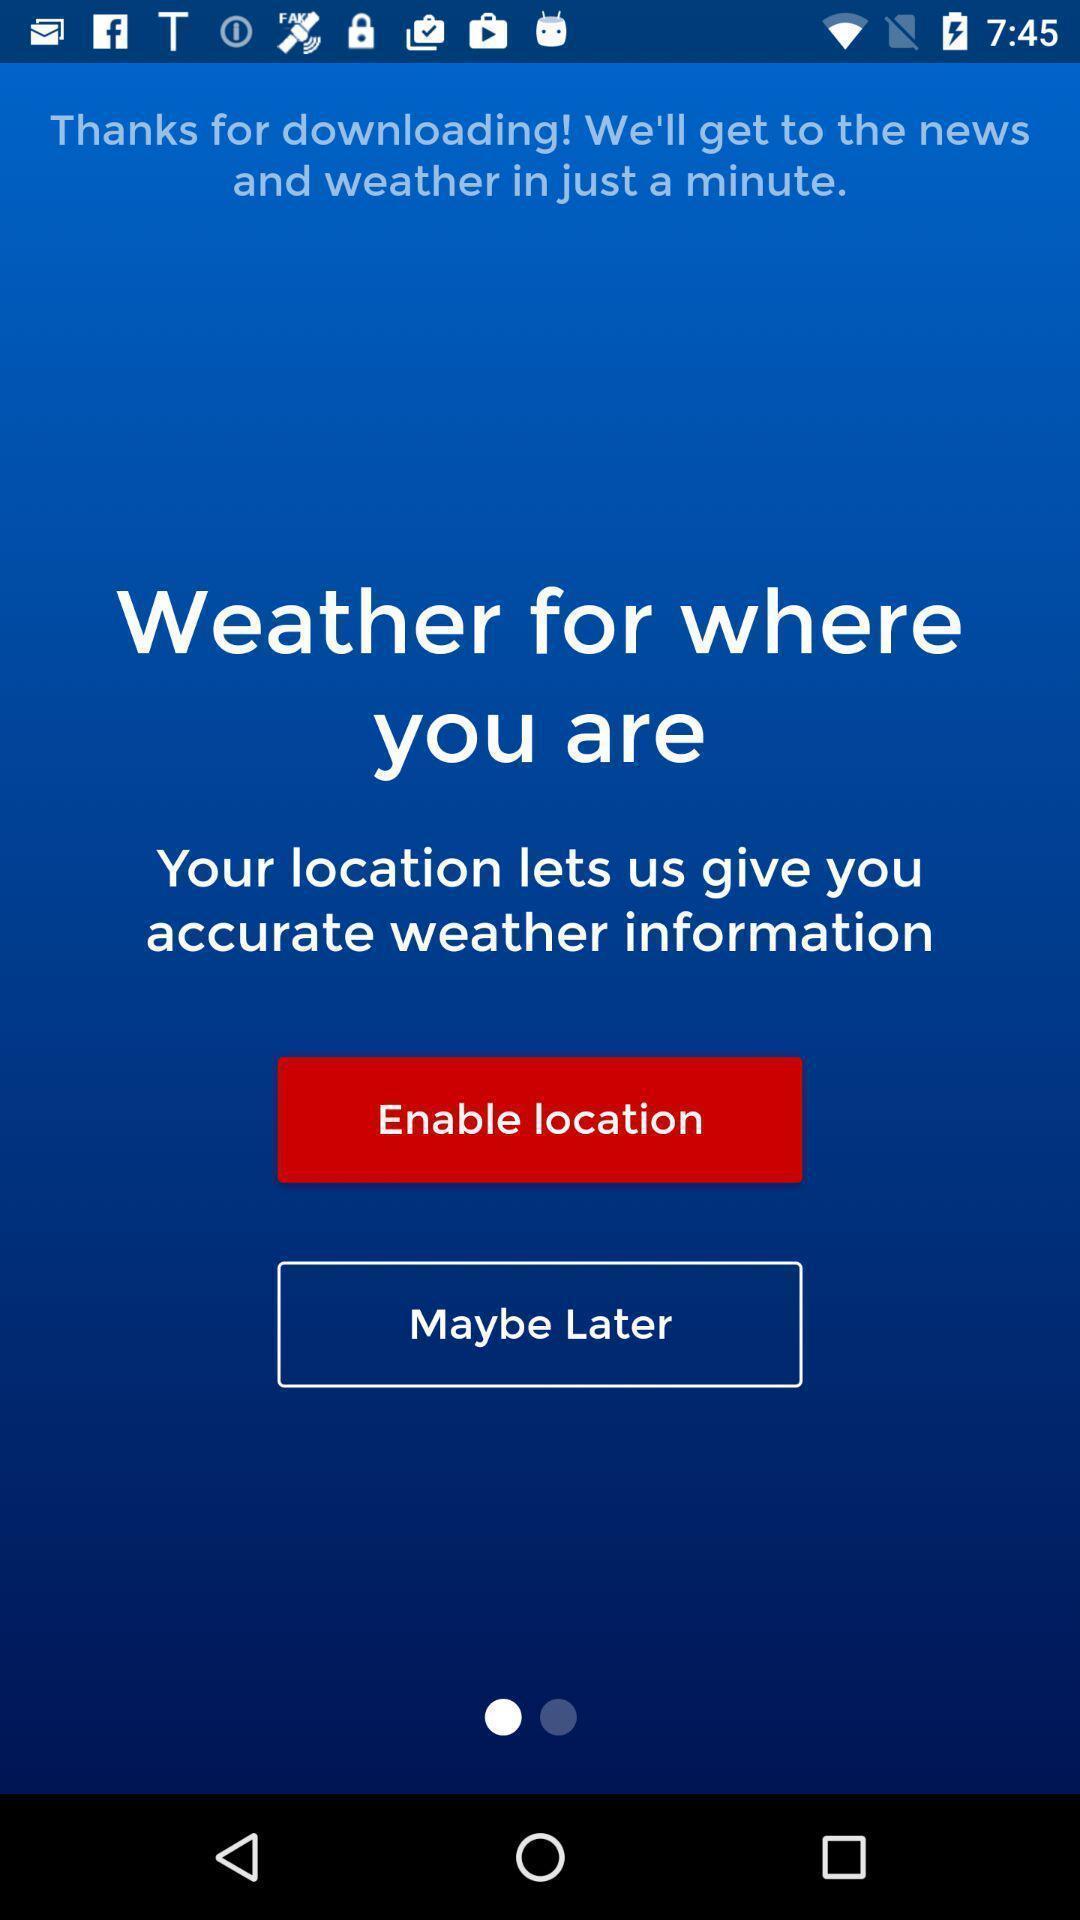Describe this image in words. Welcome page of a news app. 